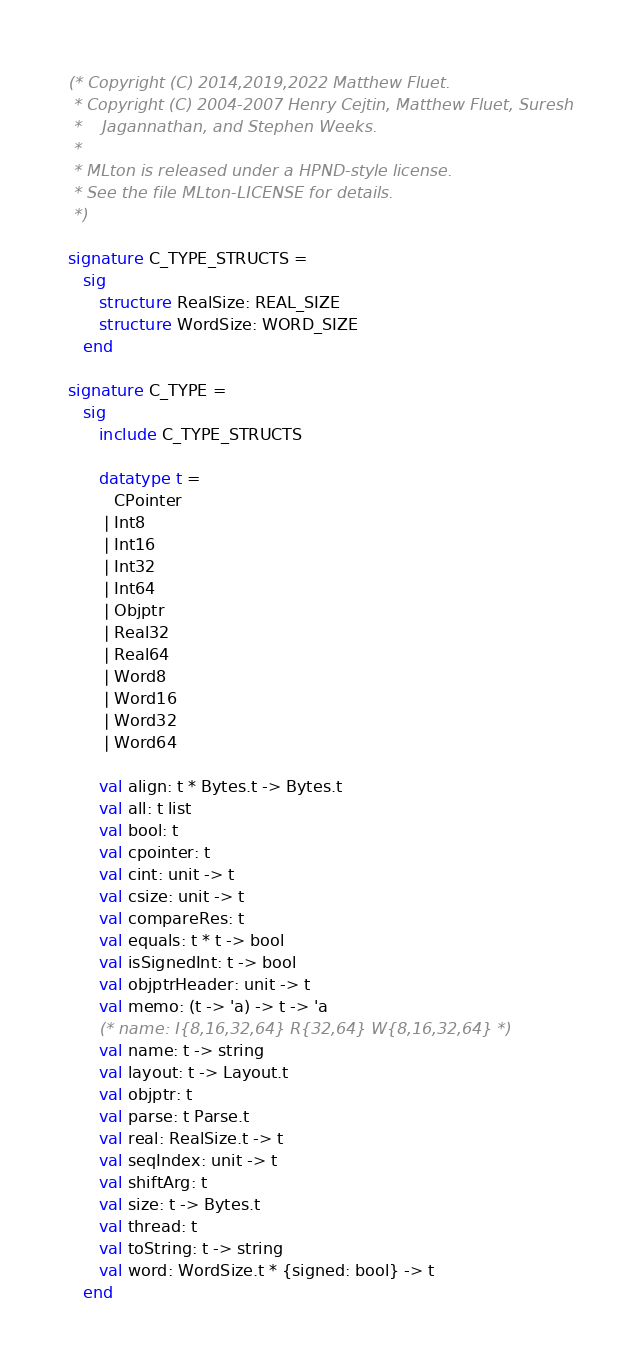Convert code to text. <code><loc_0><loc_0><loc_500><loc_500><_SML_>(* Copyright (C) 2014,2019,2022 Matthew Fluet.
 * Copyright (C) 2004-2007 Henry Cejtin, Matthew Fluet, Suresh
 *    Jagannathan, and Stephen Weeks.
 *
 * MLton is released under a HPND-style license.
 * See the file MLton-LICENSE for details.
 *)

signature C_TYPE_STRUCTS =
   sig
      structure RealSize: REAL_SIZE
      structure WordSize: WORD_SIZE
   end

signature C_TYPE =
   sig
      include C_TYPE_STRUCTS

      datatype t =
         CPointer
       | Int8
       | Int16
       | Int32
       | Int64
       | Objptr
       | Real32
       | Real64
       | Word8
       | Word16
       | Word32
       | Word64

      val align: t * Bytes.t -> Bytes.t
      val all: t list
      val bool: t
      val cpointer: t
      val cint: unit -> t
      val csize: unit -> t
      val compareRes: t
      val equals: t * t -> bool
      val isSignedInt: t -> bool
      val objptrHeader: unit -> t
      val memo: (t -> 'a) -> t -> 'a
      (* name: I{8,16,32,64} R{32,64} W{8,16,32,64} *)
      val name: t -> string
      val layout: t -> Layout.t
      val objptr: t
      val parse: t Parse.t
      val real: RealSize.t -> t
      val seqIndex: unit -> t
      val shiftArg: t
      val size: t -> Bytes.t
      val thread: t
      val toString: t -> string
      val word: WordSize.t * {signed: bool} -> t
   end
</code> 